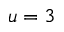Convert formula to latex. <formula><loc_0><loc_0><loc_500><loc_500>u = 3</formula> 